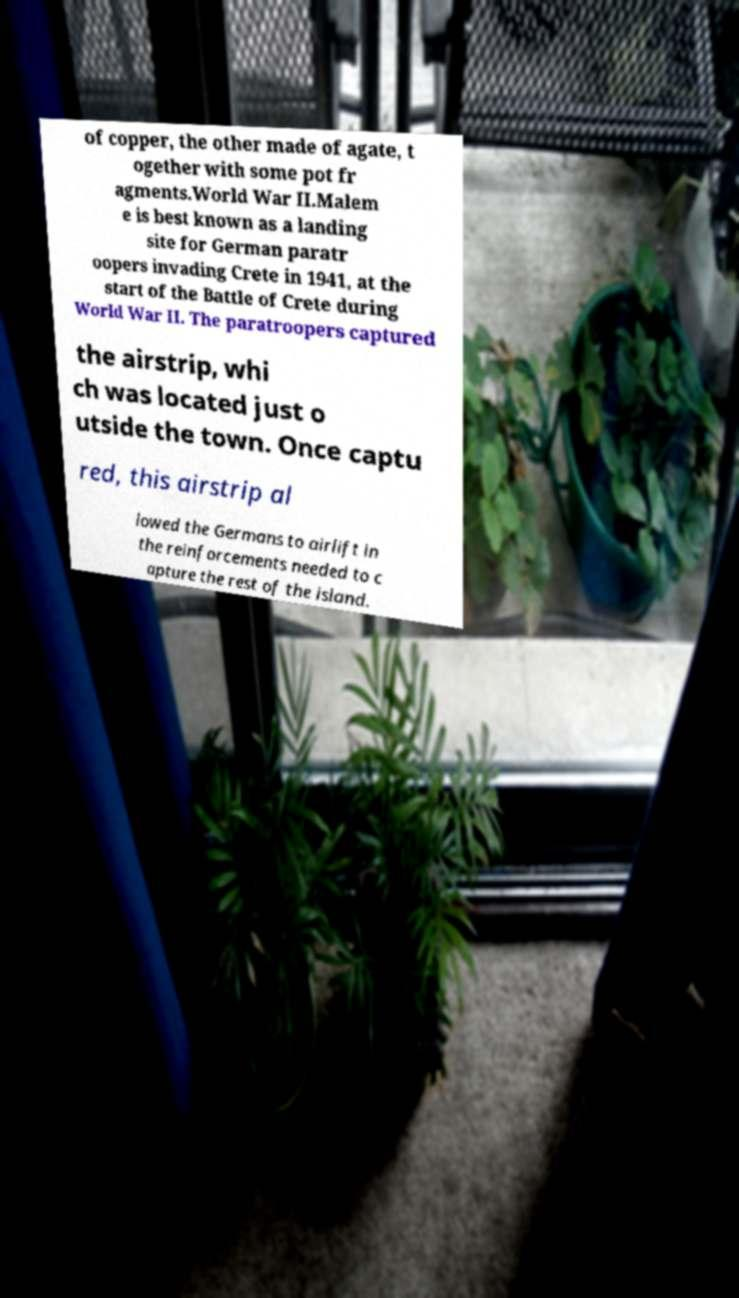There's text embedded in this image that I need extracted. Can you transcribe it verbatim? of copper, the other made of agate, t ogether with some pot fr agments.World War II.Malem e is best known as a landing site for German paratr oopers invading Crete in 1941, at the start of the Battle of Crete during World War II. The paratroopers captured the airstrip, whi ch was located just o utside the town. Once captu red, this airstrip al lowed the Germans to airlift in the reinforcements needed to c apture the rest of the island. 